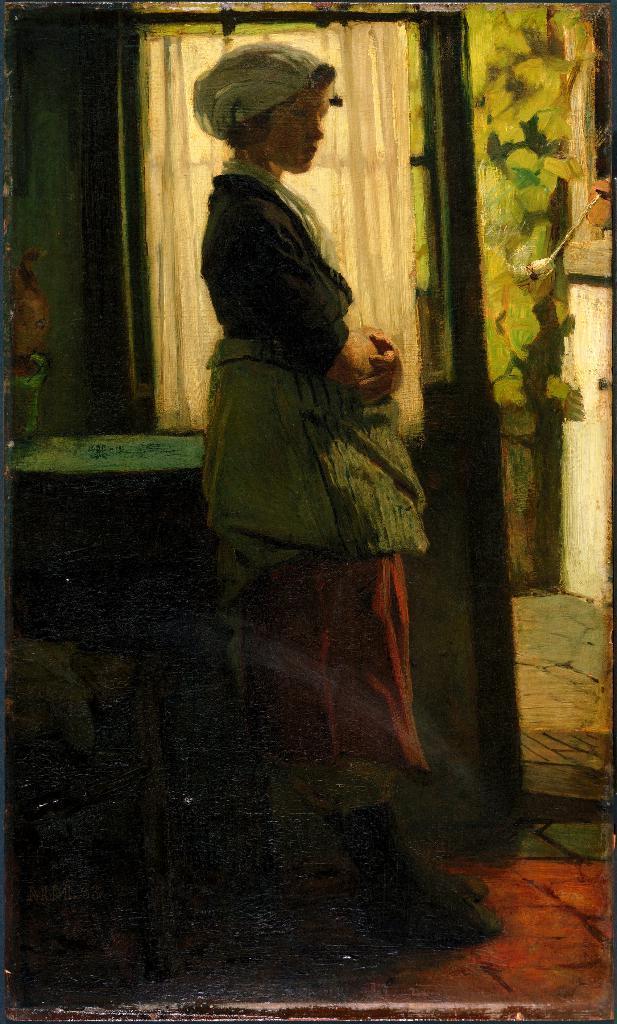Can you describe this image briefly? In this image we can see a woman standing on the floor, beside her there is a table. On the table there is an object, back of her there is a wall. 